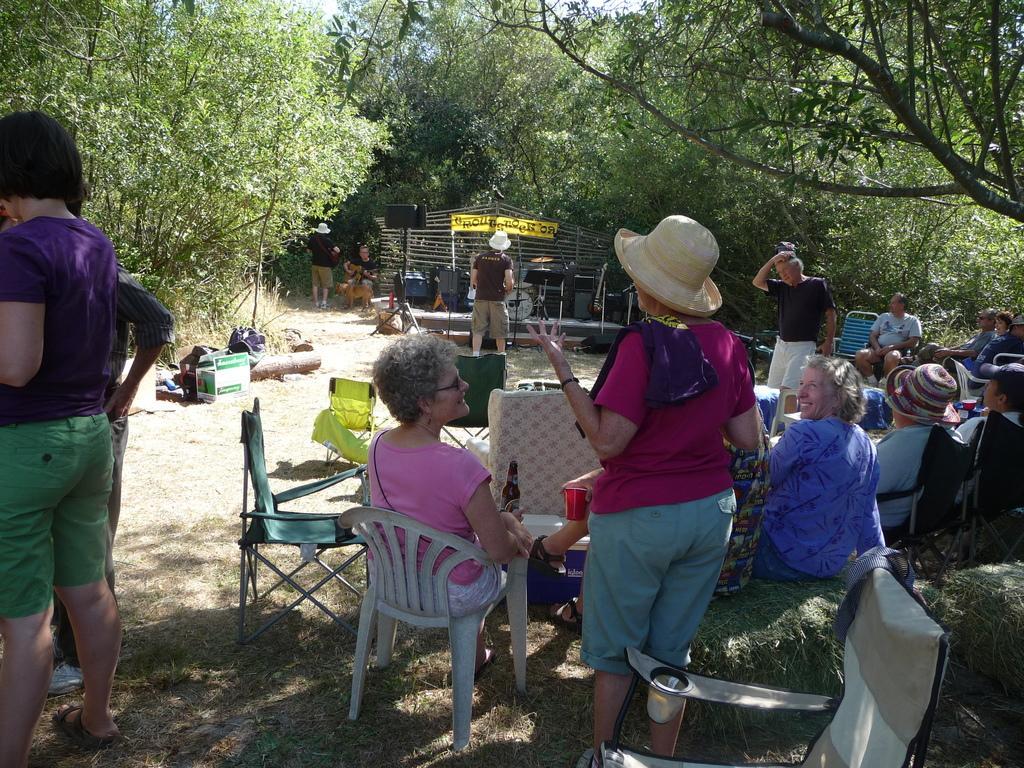Could you give a brief overview of what you see in this image? This picture shows a group of people seated on the chairs and we see people standing and we see few trees around and we see a woman holding a glass in her hand. 